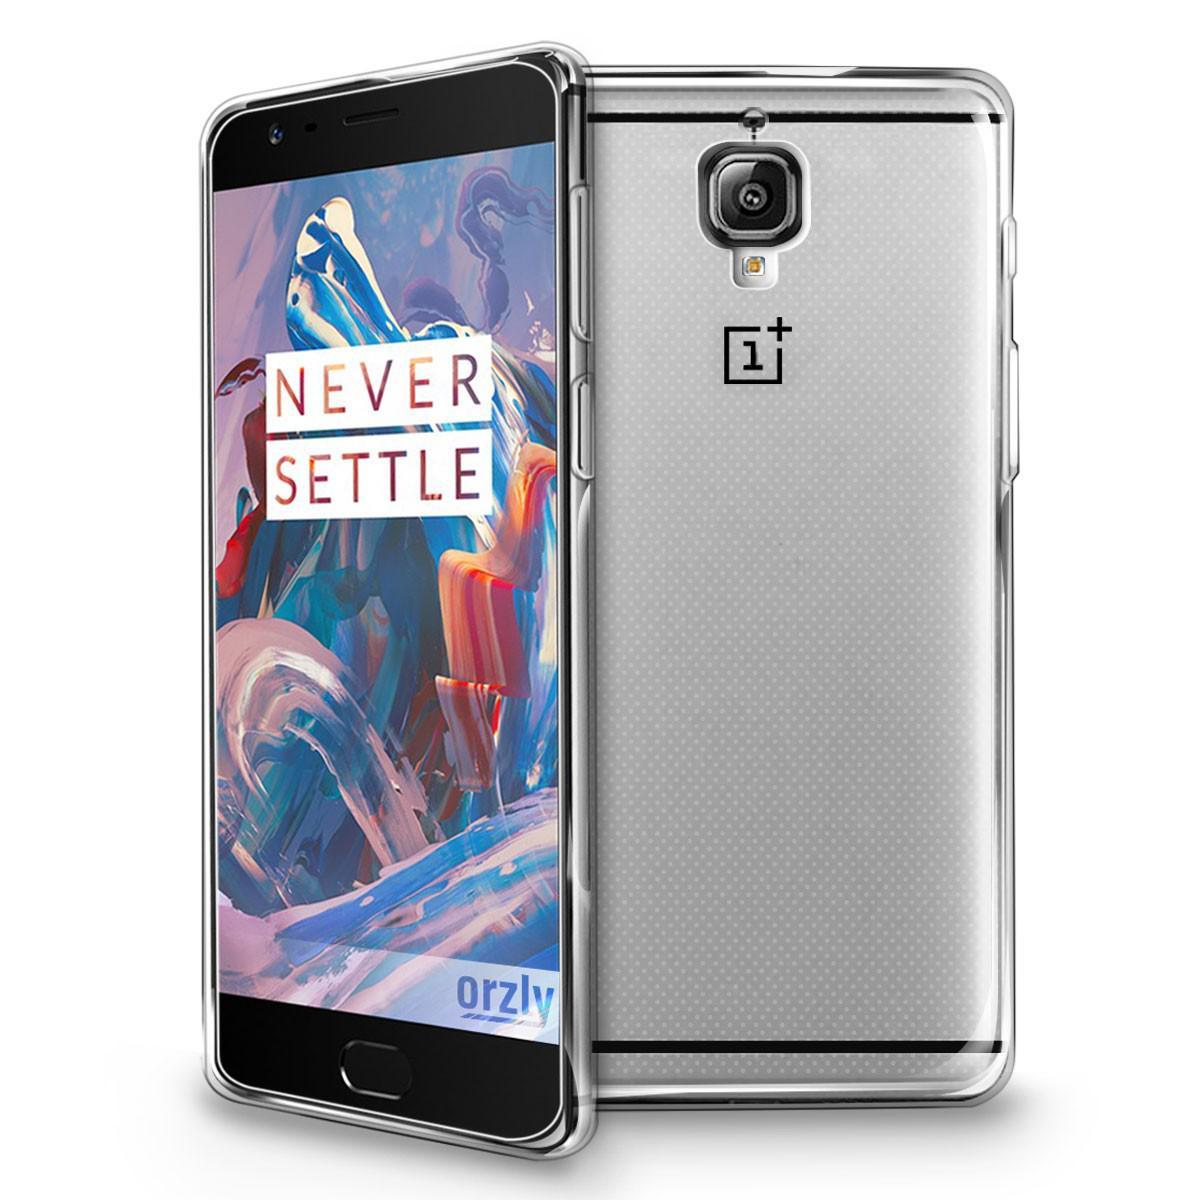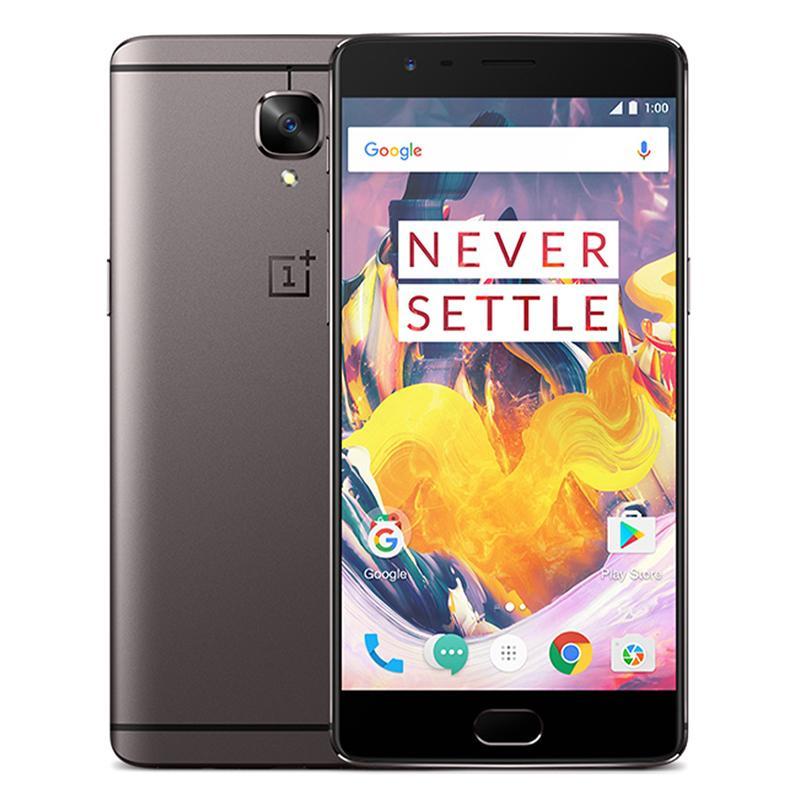The first image is the image on the left, the second image is the image on the right. Analyze the images presented: Is the assertion "The left and right image contains the same number of phones with the front side parallel with the back of the other phone." valid? Answer yes or no. No. 